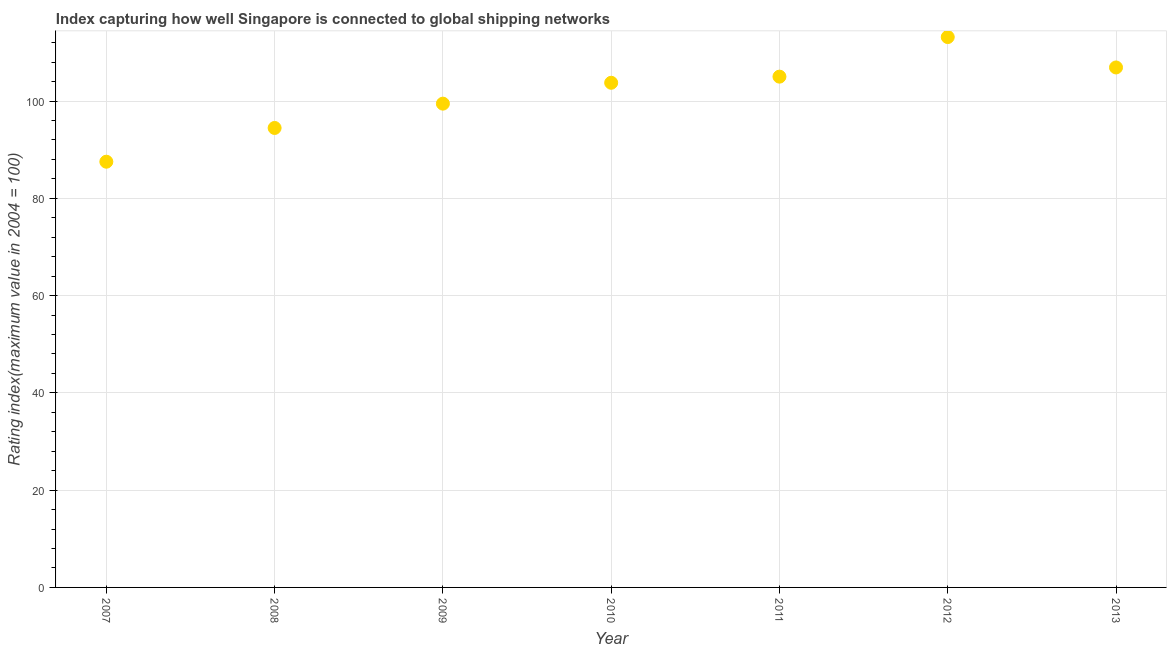What is the liner shipping connectivity index in 2010?
Ensure brevity in your answer.  103.76. Across all years, what is the maximum liner shipping connectivity index?
Your answer should be very brief. 113.16. Across all years, what is the minimum liner shipping connectivity index?
Provide a short and direct response. 87.53. What is the sum of the liner shipping connectivity index?
Your answer should be very brief. 710.32. What is the difference between the liner shipping connectivity index in 2010 and 2012?
Your response must be concise. -9.4. What is the average liner shipping connectivity index per year?
Your response must be concise. 101.47. What is the median liner shipping connectivity index?
Offer a very short reply. 103.76. Do a majority of the years between 2007 and 2008 (inclusive) have liner shipping connectivity index greater than 64 ?
Your answer should be compact. Yes. What is the ratio of the liner shipping connectivity index in 2007 to that in 2008?
Provide a short and direct response. 0.93. Is the liner shipping connectivity index in 2010 less than that in 2012?
Your answer should be compact. Yes. What is the difference between the highest and the second highest liner shipping connectivity index?
Your response must be concise. 6.25. Is the sum of the liner shipping connectivity index in 2008 and 2010 greater than the maximum liner shipping connectivity index across all years?
Provide a succinct answer. Yes. What is the difference between the highest and the lowest liner shipping connectivity index?
Offer a very short reply. 25.63. Does the liner shipping connectivity index monotonically increase over the years?
Your answer should be very brief. No. How many years are there in the graph?
Offer a very short reply. 7. Are the values on the major ticks of Y-axis written in scientific E-notation?
Your response must be concise. No. Does the graph contain grids?
Give a very brief answer. Yes. What is the title of the graph?
Provide a succinct answer. Index capturing how well Singapore is connected to global shipping networks. What is the label or title of the Y-axis?
Keep it short and to the point. Rating index(maximum value in 2004 = 100). What is the Rating index(maximum value in 2004 = 100) in 2007?
Keep it short and to the point. 87.53. What is the Rating index(maximum value in 2004 = 100) in 2008?
Keep it short and to the point. 94.47. What is the Rating index(maximum value in 2004 = 100) in 2009?
Provide a short and direct response. 99.47. What is the Rating index(maximum value in 2004 = 100) in 2010?
Give a very brief answer. 103.76. What is the Rating index(maximum value in 2004 = 100) in 2011?
Keep it short and to the point. 105.02. What is the Rating index(maximum value in 2004 = 100) in 2012?
Your response must be concise. 113.16. What is the Rating index(maximum value in 2004 = 100) in 2013?
Give a very brief answer. 106.91. What is the difference between the Rating index(maximum value in 2004 = 100) in 2007 and 2008?
Provide a succinct answer. -6.94. What is the difference between the Rating index(maximum value in 2004 = 100) in 2007 and 2009?
Make the answer very short. -11.94. What is the difference between the Rating index(maximum value in 2004 = 100) in 2007 and 2010?
Give a very brief answer. -16.23. What is the difference between the Rating index(maximum value in 2004 = 100) in 2007 and 2011?
Your answer should be compact. -17.49. What is the difference between the Rating index(maximum value in 2004 = 100) in 2007 and 2012?
Provide a short and direct response. -25.63. What is the difference between the Rating index(maximum value in 2004 = 100) in 2007 and 2013?
Provide a succinct answer. -19.38. What is the difference between the Rating index(maximum value in 2004 = 100) in 2008 and 2010?
Ensure brevity in your answer.  -9.29. What is the difference between the Rating index(maximum value in 2004 = 100) in 2008 and 2011?
Offer a terse response. -10.55. What is the difference between the Rating index(maximum value in 2004 = 100) in 2008 and 2012?
Keep it short and to the point. -18.69. What is the difference between the Rating index(maximum value in 2004 = 100) in 2008 and 2013?
Your answer should be very brief. -12.44. What is the difference between the Rating index(maximum value in 2004 = 100) in 2009 and 2010?
Make the answer very short. -4.29. What is the difference between the Rating index(maximum value in 2004 = 100) in 2009 and 2011?
Your response must be concise. -5.55. What is the difference between the Rating index(maximum value in 2004 = 100) in 2009 and 2012?
Your answer should be compact. -13.69. What is the difference between the Rating index(maximum value in 2004 = 100) in 2009 and 2013?
Ensure brevity in your answer.  -7.44. What is the difference between the Rating index(maximum value in 2004 = 100) in 2010 and 2011?
Keep it short and to the point. -1.26. What is the difference between the Rating index(maximum value in 2004 = 100) in 2010 and 2012?
Ensure brevity in your answer.  -9.4. What is the difference between the Rating index(maximum value in 2004 = 100) in 2010 and 2013?
Provide a succinct answer. -3.15. What is the difference between the Rating index(maximum value in 2004 = 100) in 2011 and 2012?
Offer a terse response. -8.14. What is the difference between the Rating index(maximum value in 2004 = 100) in 2011 and 2013?
Ensure brevity in your answer.  -1.89. What is the difference between the Rating index(maximum value in 2004 = 100) in 2012 and 2013?
Your answer should be compact. 6.25. What is the ratio of the Rating index(maximum value in 2004 = 100) in 2007 to that in 2008?
Your response must be concise. 0.93. What is the ratio of the Rating index(maximum value in 2004 = 100) in 2007 to that in 2010?
Keep it short and to the point. 0.84. What is the ratio of the Rating index(maximum value in 2004 = 100) in 2007 to that in 2011?
Your answer should be very brief. 0.83. What is the ratio of the Rating index(maximum value in 2004 = 100) in 2007 to that in 2012?
Ensure brevity in your answer.  0.77. What is the ratio of the Rating index(maximum value in 2004 = 100) in 2007 to that in 2013?
Provide a succinct answer. 0.82. What is the ratio of the Rating index(maximum value in 2004 = 100) in 2008 to that in 2010?
Provide a succinct answer. 0.91. What is the ratio of the Rating index(maximum value in 2004 = 100) in 2008 to that in 2011?
Give a very brief answer. 0.9. What is the ratio of the Rating index(maximum value in 2004 = 100) in 2008 to that in 2012?
Keep it short and to the point. 0.83. What is the ratio of the Rating index(maximum value in 2004 = 100) in 2008 to that in 2013?
Your answer should be very brief. 0.88. What is the ratio of the Rating index(maximum value in 2004 = 100) in 2009 to that in 2011?
Provide a succinct answer. 0.95. What is the ratio of the Rating index(maximum value in 2004 = 100) in 2009 to that in 2012?
Your answer should be compact. 0.88. What is the ratio of the Rating index(maximum value in 2004 = 100) in 2009 to that in 2013?
Make the answer very short. 0.93. What is the ratio of the Rating index(maximum value in 2004 = 100) in 2010 to that in 2011?
Your response must be concise. 0.99. What is the ratio of the Rating index(maximum value in 2004 = 100) in 2010 to that in 2012?
Your answer should be very brief. 0.92. What is the ratio of the Rating index(maximum value in 2004 = 100) in 2010 to that in 2013?
Offer a terse response. 0.97. What is the ratio of the Rating index(maximum value in 2004 = 100) in 2011 to that in 2012?
Provide a short and direct response. 0.93. What is the ratio of the Rating index(maximum value in 2004 = 100) in 2011 to that in 2013?
Ensure brevity in your answer.  0.98. What is the ratio of the Rating index(maximum value in 2004 = 100) in 2012 to that in 2013?
Keep it short and to the point. 1.06. 